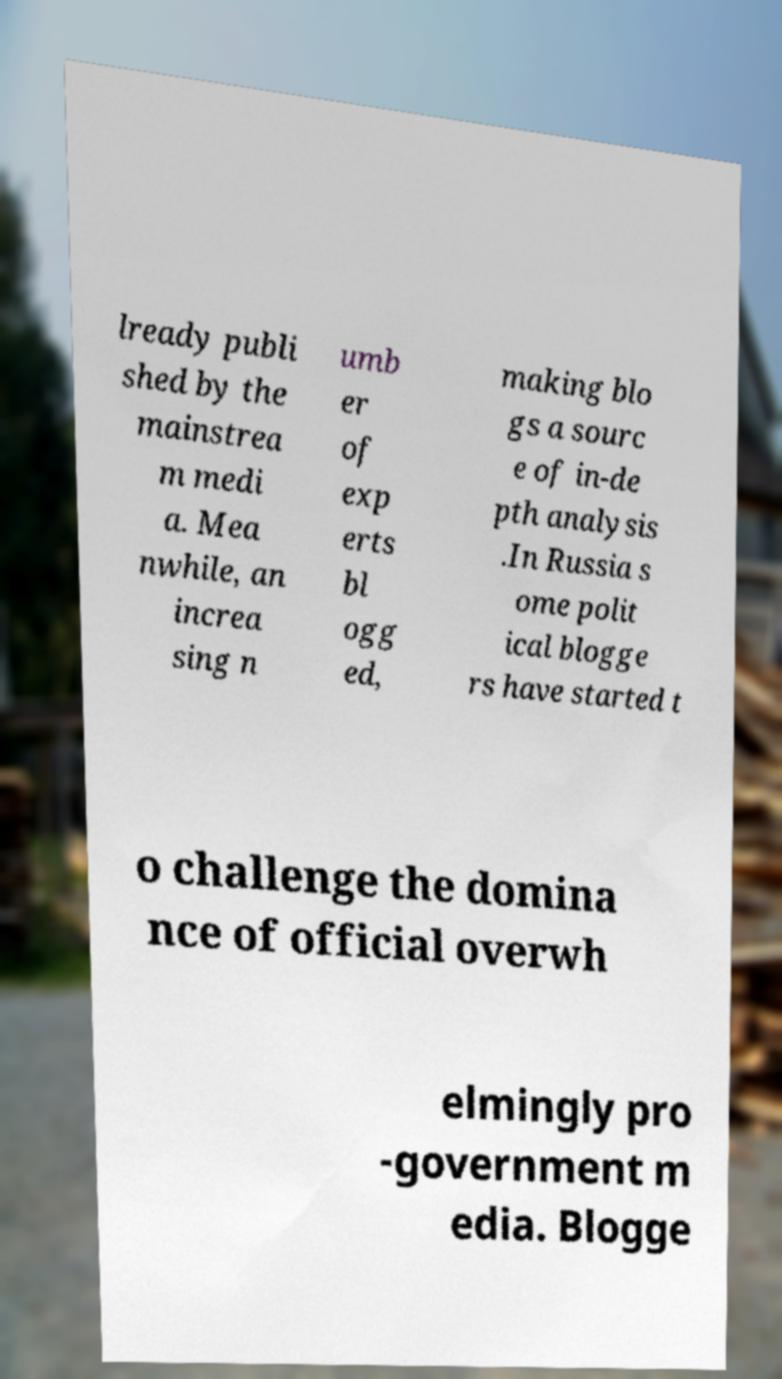Could you assist in decoding the text presented in this image and type it out clearly? lready publi shed by the mainstrea m medi a. Mea nwhile, an increa sing n umb er of exp erts bl ogg ed, making blo gs a sourc e of in-de pth analysis .In Russia s ome polit ical blogge rs have started t o challenge the domina nce of official overwh elmingly pro -government m edia. Blogge 